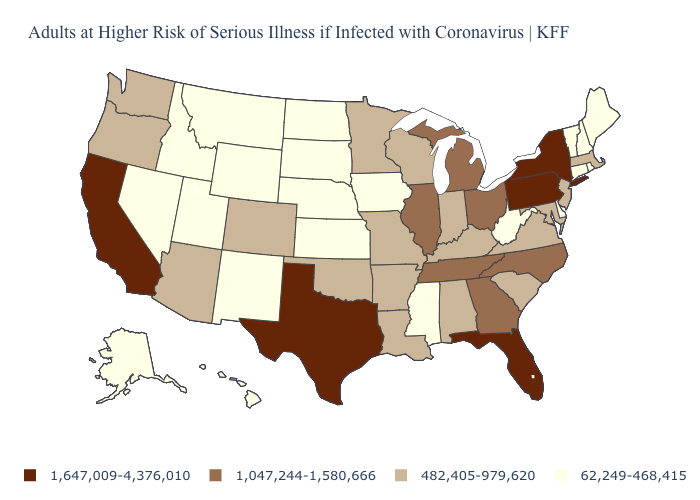Does New York have the highest value in the USA?
Write a very short answer. Yes. Name the states that have a value in the range 62,249-468,415?
Give a very brief answer. Alaska, Connecticut, Delaware, Hawaii, Idaho, Iowa, Kansas, Maine, Mississippi, Montana, Nebraska, Nevada, New Hampshire, New Mexico, North Dakota, Rhode Island, South Dakota, Utah, Vermont, West Virginia, Wyoming. Name the states that have a value in the range 62,249-468,415?
Concise answer only. Alaska, Connecticut, Delaware, Hawaii, Idaho, Iowa, Kansas, Maine, Mississippi, Montana, Nebraska, Nevada, New Hampshire, New Mexico, North Dakota, Rhode Island, South Dakota, Utah, Vermont, West Virginia, Wyoming. Is the legend a continuous bar?
Answer briefly. No. Does the map have missing data?
Concise answer only. No. What is the value of Montana?
Be succinct. 62,249-468,415. What is the value of Idaho?
Give a very brief answer. 62,249-468,415. What is the lowest value in states that border Wyoming?
Give a very brief answer. 62,249-468,415. Among the states that border Arizona , does New Mexico have the lowest value?
Give a very brief answer. Yes. Among the states that border Arizona , which have the lowest value?
Short answer required. Nevada, New Mexico, Utah. What is the value of Pennsylvania?
Write a very short answer. 1,647,009-4,376,010. Name the states that have a value in the range 1,647,009-4,376,010?
Write a very short answer. California, Florida, New York, Pennsylvania, Texas. Name the states that have a value in the range 1,047,244-1,580,666?
Give a very brief answer. Georgia, Illinois, Michigan, North Carolina, Ohio, Tennessee. Does the first symbol in the legend represent the smallest category?
Give a very brief answer. No. What is the lowest value in the South?
Concise answer only. 62,249-468,415. 